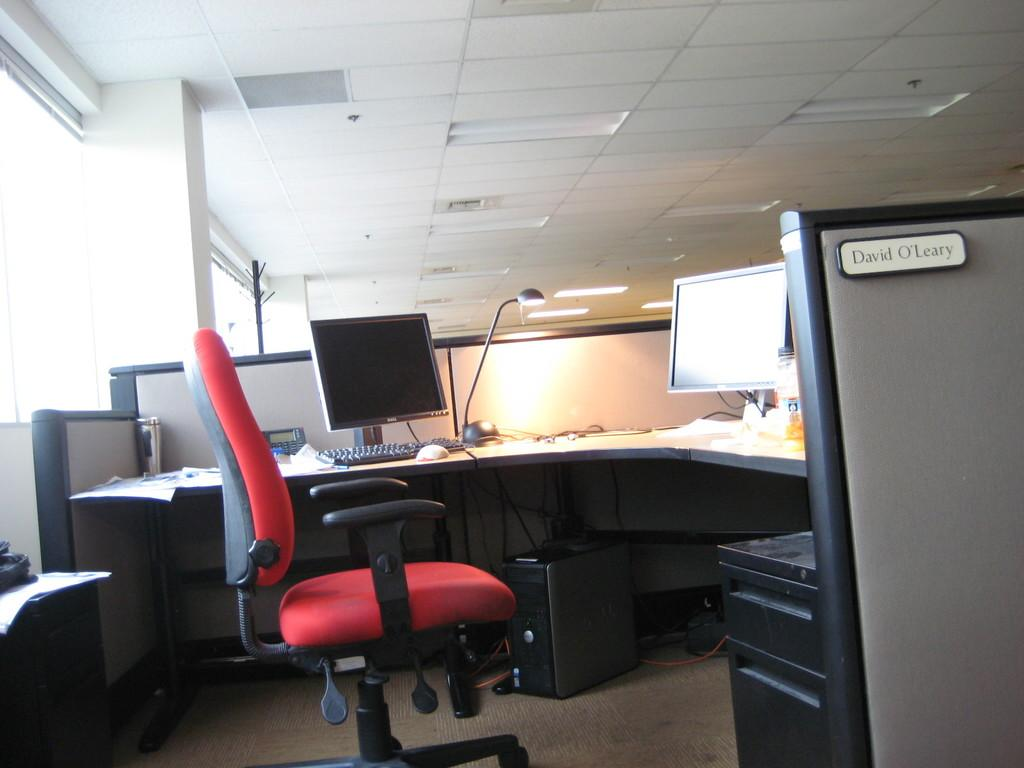<image>
Give a short and clear explanation of the subsequent image. cubicle for david o'leary featuring a red office chair and two dell monitors 